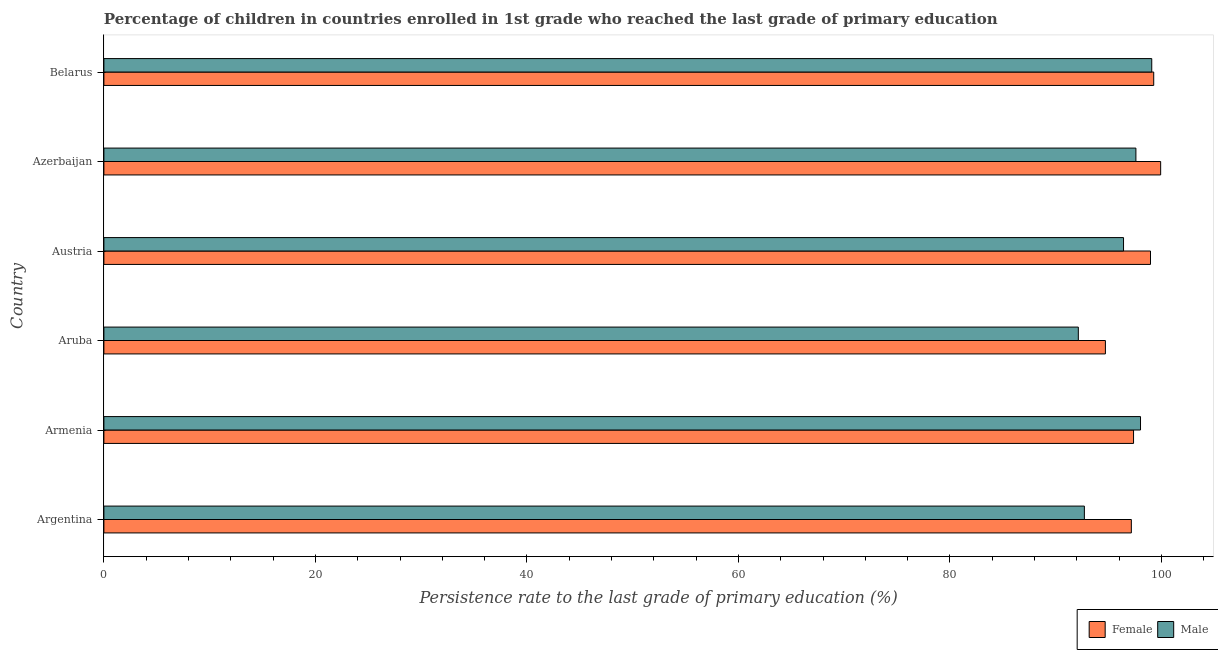How many different coloured bars are there?
Provide a short and direct response. 2. How many groups of bars are there?
Give a very brief answer. 6. Are the number of bars per tick equal to the number of legend labels?
Ensure brevity in your answer.  Yes. How many bars are there on the 4th tick from the top?
Your response must be concise. 2. What is the label of the 4th group of bars from the top?
Your answer should be compact. Aruba. What is the persistence rate of female students in Azerbaijan?
Your answer should be compact. 99.92. Across all countries, what is the maximum persistence rate of female students?
Provide a short and direct response. 99.92. Across all countries, what is the minimum persistence rate of male students?
Offer a very short reply. 92.13. In which country was the persistence rate of female students maximum?
Provide a short and direct response. Azerbaijan. In which country was the persistence rate of female students minimum?
Make the answer very short. Aruba. What is the total persistence rate of female students in the graph?
Provide a short and direct response. 587.34. What is the difference between the persistence rate of female students in Argentina and that in Aruba?
Your answer should be compact. 2.45. What is the difference between the persistence rate of female students in Argentina and the persistence rate of male students in Armenia?
Provide a succinct answer. -0.87. What is the average persistence rate of male students per country?
Your answer should be very brief. 95.99. What is the difference between the persistence rate of female students and persistence rate of male students in Aruba?
Provide a succinct answer. 2.56. In how many countries, is the persistence rate of male students greater than 44 %?
Keep it short and to the point. 6. Is the persistence rate of male students in Armenia less than that in Austria?
Your answer should be compact. No. Is the difference between the persistence rate of female students in Aruba and Belarus greater than the difference between the persistence rate of male students in Aruba and Belarus?
Keep it short and to the point. Yes. What is the difference between the highest and the second highest persistence rate of female students?
Offer a very short reply. 0.66. What is the difference between the highest and the lowest persistence rate of female students?
Make the answer very short. 5.22. In how many countries, is the persistence rate of male students greater than the average persistence rate of male students taken over all countries?
Make the answer very short. 4. Is the sum of the persistence rate of male students in Armenia and Austria greater than the maximum persistence rate of female students across all countries?
Your answer should be very brief. Yes. What does the 2nd bar from the top in Armenia represents?
Your answer should be very brief. Female. What does the 2nd bar from the bottom in Armenia represents?
Ensure brevity in your answer.  Male. How many countries are there in the graph?
Your response must be concise. 6. Are the values on the major ticks of X-axis written in scientific E-notation?
Your response must be concise. No. Where does the legend appear in the graph?
Give a very brief answer. Bottom right. How are the legend labels stacked?
Provide a succinct answer. Horizontal. What is the title of the graph?
Your response must be concise. Percentage of children in countries enrolled in 1st grade who reached the last grade of primary education. Does "Secondary Education" appear as one of the legend labels in the graph?
Ensure brevity in your answer.  No. What is the label or title of the X-axis?
Give a very brief answer. Persistence rate to the last grade of primary education (%). What is the label or title of the Y-axis?
Provide a succinct answer. Country. What is the Persistence rate to the last grade of primary education (%) of Female in Argentina?
Keep it short and to the point. 97.15. What is the Persistence rate to the last grade of primary education (%) of Male in Argentina?
Your response must be concise. 92.71. What is the Persistence rate to the last grade of primary education (%) of Female in Armenia?
Your response must be concise. 97.36. What is the Persistence rate to the last grade of primary education (%) of Male in Armenia?
Give a very brief answer. 98.01. What is the Persistence rate to the last grade of primary education (%) in Female in Aruba?
Your response must be concise. 94.7. What is the Persistence rate to the last grade of primary education (%) of Male in Aruba?
Your answer should be compact. 92.13. What is the Persistence rate to the last grade of primary education (%) in Female in Austria?
Ensure brevity in your answer.  98.96. What is the Persistence rate to the last grade of primary education (%) in Male in Austria?
Offer a very short reply. 96.41. What is the Persistence rate to the last grade of primary education (%) in Female in Azerbaijan?
Give a very brief answer. 99.92. What is the Persistence rate to the last grade of primary education (%) in Male in Azerbaijan?
Keep it short and to the point. 97.58. What is the Persistence rate to the last grade of primary education (%) of Female in Belarus?
Provide a short and direct response. 99.26. What is the Persistence rate to the last grade of primary education (%) of Male in Belarus?
Your answer should be very brief. 99.08. Across all countries, what is the maximum Persistence rate to the last grade of primary education (%) in Female?
Provide a succinct answer. 99.92. Across all countries, what is the maximum Persistence rate to the last grade of primary education (%) in Male?
Provide a succinct answer. 99.08. Across all countries, what is the minimum Persistence rate to the last grade of primary education (%) of Female?
Offer a very short reply. 94.7. Across all countries, what is the minimum Persistence rate to the last grade of primary education (%) of Male?
Your response must be concise. 92.13. What is the total Persistence rate to the last grade of primary education (%) of Female in the graph?
Your answer should be very brief. 587.34. What is the total Persistence rate to the last grade of primary education (%) in Male in the graph?
Provide a succinct answer. 575.92. What is the difference between the Persistence rate to the last grade of primary education (%) in Female in Argentina and that in Armenia?
Offer a very short reply. -0.21. What is the difference between the Persistence rate to the last grade of primary education (%) of Male in Argentina and that in Armenia?
Your answer should be very brief. -5.31. What is the difference between the Persistence rate to the last grade of primary education (%) in Female in Argentina and that in Aruba?
Give a very brief answer. 2.45. What is the difference between the Persistence rate to the last grade of primary education (%) in Male in Argentina and that in Aruba?
Make the answer very short. 0.57. What is the difference between the Persistence rate to the last grade of primary education (%) of Female in Argentina and that in Austria?
Your answer should be compact. -1.81. What is the difference between the Persistence rate to the last grade of primary education (%) of Male in Argentina and that in Austria?
Make the answer very short. -3.7. What is the difference between the Persistence rate to the last grade of primary education (%) of Female in Argentina and that in Azerbaijan?
Your answer should be compact. -2.77. What is the difference between the Persistence rate to the last grade of primary education (%) of Male in Argentina and that in Azerbaijan?
Your answer should be compact. -4.87. What is the difference between the Persistence rate to the last grade of primary education (%) of Female in Argentina and that in Belarus?
Offer a terse response. -2.11. What is the difference between the Persistence rate to the last grade of primary education (%) of Male in Argentina and that in Belarus?
Your answer should be very brief. -6.37. What is the difference between the Persistence rate to the last grade of primary education (%) of Female in Armenia and that in Aruba?
Make the answer very short. 2.66. What is the difference between the Persistence rate to the last grade of primary education (%) of Male in Armenia and that in Aruba?
Give a very brief answer. 5.88. What is the difference between the Persistence rate to the last grade of primary education (%) of Female in Armenia and that in Austria?
Your answer should be very brief. -1.6. What is the difference between the Persistence rate to the last grade of primary education (%) of Male in Armenia and that in Austria?
Make the answer very short. 1.61. What is the difference between the Persistence rate to the last grade of primary education (%) in Female in Armenia and that in Azerbaijan?
Your answer should be compact. -2.56. What is the difference between the Persistence rate to the last grade of primary education (%) in Male in Armenia and that in Azerbaijan?
Make the answer very short. 0.43. What is the difference between the Persistence rate to the last grade of primary education (%) of Female in Armenia and that in Belarus?
Make the answer very short. -1.91. What is the difference between the Persistence rate to the last grade of primary education (%) in Male in Armenia and that in Belarus?
Keep it short and to the point. -1.06. What is the difference between the Persistence rate to the last grade of primary education (%) in Female in Aruba and that in Austria?
Your answer should be compact. -4.26. What is the difference between the Persistence rate to the last grade of primary education (%) of Male in Aruba and that in Austria?
Offer a very short reply. -4.28. What is the difference between the Persistence rate to the last grade of primary education (%) of Female in Aruba and that in Azerbaijan?
Ensure brevity in your answer.  -5.22. What is the difference between the Persistence rate to the last grade of primary education (%) in Male in Aruba and that in Azerbaijan?
Offer a terse response. -5.45. What is the difference between the Persistence rate to the last grade of primary education (%) in Female in Aruba and that in Belarus?
Your answer should be very brief. -4.57. What is the difference between the Persistence rate to the last grade of primary education (%) of Male in Aruba and that in Belarus?
Offer a very short reply. -6.94. What is the difference between the Persistence rate to the last grade of primary education (%) of Female in Austria and that in Azerbaijan?
Keep it short and to the point. -0.96. What is the difference between the Persistence rate to the last grade of primary education (%) of Male in Austria and that in Azerbaijan?
Your answer should be compact. -1.17. What is the difference between the Persistence rate to the last grade of primary education (%) in Female in Austria and that in Belarus?
Your response must be concise. -0.3. What is the difference between the Persistence rate to the last grade of primary education (%) in Male in Austria and that in Belarus?
Your response must be concise. -2.67. What is the difference between the Persistence rate to the last grade of primary education (%) of Female in Azerbaijan and that in Belarus?
Ensure brevity in your answer.  0.66. What is the difference between the Persistence rate to the last grade of primary education (%) in Male in Azerbaijan and that in Belarus?
Provide a short and direct response. -1.5. What is the difference between the Persistence rate to the last grade of primary education (%) of Female in Argentina and the Persistence rate to the last grade of primary education (%) of Male in Armenia?
Ensure brevity in your answer.  -0.87. What is the difference between the Persistence rate to the last grade of primary education (%) in Female in Argentina and the Persistence rate to the last grade of primary education (%) in Male in Aruba?
Make the answer very short. 5.01. What is the difference between the Persistence rate to the last grade of primary education (%) of Female in Argentina and the Persistence rate to the last grade of primary education (%) of Male in Austria?
Ensure brevity in your answer.  0.74. What is the difference between the Persistence rate to the last grade of primary education (%) in Female in Argentina and the Persistence rate to the last grade of primary education (%) in Male in Azerbaijan?
Give a very brief answer. -0.43. What is the difference between the Persistence rate to the last grade of primary education (%) of Female in Argentina and the Persistence rate to the last grade of primary education (%) of Male in Belarus?
Your answer should be compact. -1.93. What is the difference between the Persistence rate to the last grade of primary education (%) of Female in Armenia and the Persistence rate to the last grade of primary education (%) of Male in Aruba?
Your answer should be very brief. 5.22. What is the difference between the Persistence rate to the last grade of primary education (%) of Female in Armenia and the Persistence rate to the last grade of primary education (%) of Male in Austria?
Provide a succinct answer. 0.95. What is the difference between the Persistence rate to the last grade of primary education (%) of Female in Armenia and the Persistence rate to the last grade of primary education (%) of Male in Azerbaijan?
Ensure brevity in your answer.  -0.22. What is the difference between the Persistence rate to the last grade of primary education (%) in Female in Armenia and the Persistence rate to the last grade of primary education (%) in Male in Belarus?
Give a very brief answer. -1.72. What is the difference between the Persistence rate to the last grade of primary education (%) in Female in Aruba and the Persistence rate to the last grade of primary education (%) in Male in Austria?
Keep it short and to the point. -1.71. What is the difference between the Persistence rate to the last grade of primary education (%) in Female in Aruba and the Persistence rate to the last grade of primary education (%) in Male in Azerbaijan?
Your answer should be compact. -2.88. What is the difference between the Persistence rate to the last grade of primary education (%) in Female in Aruba and the Persistence rate to the last grade of primary education (%) in Male in Belarus?
Your answer should be compact. -4.38. What is the difference between the Persistence rate to the last grade of primary education (%) of Female in Austria and the Persistence rate to the last grade of primary education (%) of Male in Azerbaijan?
Offer a very short reply. 1.38. What is the difference between the Persistence rate to the last grade of primary education (%) of Female in Austria and the Persistence rate to the last grade of primary education (%) of Male in Belarus?
Provide a succinct answer. -0.12. What is the difference between the Persistence rate to the last grade of primary education (%) in Female in Azerbaijan and the Persistence rate to the last grade of primary education (%) in Male in Belarus?
Your response must be concise. 0.84. What is the average Persistence rate to the last grade of primary education (%) in Female per country?
Provide a succinct answer. 97.89. What is the average Persistence rate to the last grade of primary education (%) of Male per country?
Your answer should be very brief. 95.99. What is the difference between the Persistence rate to the last grade of primary education (%) in Female and Persistence rate to the last grade of primary education (%) in Male in Argentina?
Give a very brief answer. 4.44. What is the difference between the Persistence rate to the last grade of primary education (%) in Female and Persistence rate to the last grade of primary education (%) in Male in Armenia?
Provide a succinct answer. -0.66. What is the difference between the Persistence rate to the last grade of primary education (%) in Female and Persistence rate to the last grade of primary education (%) in Male in Aruba?
Your answer should be very brief. 2.56. What is the difference between the Persistence rate to the last grade of primary education (%) of Female and Persistence rate to the last grade of primary education (%) of Male in Austria?
Your response must be concise. 2.55. What is the difference between the Persistence rate to the last grade of primary education (%) of Female and Persistence rate to the last grade of primary education (%) of Male in Azerbaijan?
Make the answer very short. 2.34. What is the difference between the Persistence rate to the last grade of primary education (%) in Female and Persistence rate to the last grade of primary education (%) in Male in Belarus?
Offer a very short reply. 0.18. What is the ratio of the Persistence rate to the last grade of primary education (%) of Male in Argentina to that in Armenia?
Your answer should be compact. 0.95. What is the ratio of the Persistence rate to the last grade of primary education (%) in Female in Argentina to that in Aruba?
Your response must be concise. 1.03. What is the ratio of the Persistence rate to the last grade of primary education (%) in Male in Argentina to that in Aruba?
Offer a very short reply. 1.01. What is the ratio of the Persistence rate to the last grade of primary education (%) in Female in Argentina to that in Austria?
Give a very brief answer. 0.98. What is the ratio of the Persistence rate to the last grade of primary education (%) in Male in Argentina to that in Austria?
Provide a succinct answer. 0.96. What is the ratio of the Persistence rate to the last grade of primary education (%) in Female in Argentina to that in Azerbaijan?
Keep it short and to the point. 0.97. What is the ratio of the Persistence rate to the last grade of primary education (%) in Male in Argentina to that in Azerbaijan?
Ensure brevity in your answer.  0.95. What is the ratio of the Persistence rate to the last grade of primary education (%) in Female in Argentina to that in Belarus?
Your response must be concise. 0.98. What is the ratio of the Persistence rate to the last grade of primary education (%) of Male in Argentina to that in Belarus?
Ensure brevity in your answer.  0.94. What is the ratio of the Persistence rate to the last grade of primary education (%) in Female in Armenia to that in Aruba?
Ensure brevity in your answer.  1.03. What is the ratio of the Persistence rate to the last grade of primary education (%) of Male in Armenia to that in Aruba?
Offer a terse response. 1.06. What is the ratio of the Persistence rate to the last grade of primary education (%) in Female in Armenia to that in Austria?
Provide a short and direct response. 0.98. What is the ratio of the Persistence rate to the last grade of primary education (%) of Male in Armenia to that in Austria?
Ensure brevity in your answer.  1.02. What is the ratio of the Persistence rate to the last grade of primary education (%) in Female in Armenia to that in Azerbaijan?
Give a very brief answer. 0.97. What is the ratio of the Persistence rate to the last grade of primary education (%) in Male in Armenia to that in Azerbaijan?
Provide a succinct answer. 1. What is the ratio of the Persistence rate to the last grade of primary education (%) of Female in Armenia to that in Belarus?
Offer a very short reply. 0.98. What is the ratio of the Persistence rate to the last grade of primary education (%) of Male in Armenia to that in Belarus?
Make the answer very short. 0.99. What is the ratio of the Persistence rate to the last grade of primary education (%) in Female in Aruba to that in Austria?
Give a very brief answer. 0.96. What is the ratio of the Persistence rate to the last grade of primary education (%) of Male in Aruba to that in Austria?
Ensure brevity in your answer.  0.96. What is the ratio of the Persistence rate to the last grade of primary education (%) in Female in Aruba to that in Azerbaijan?
Provide a succinct answer. 0.95. What is the ratio of the Persistence rate to the last grade of primary education (%) in Male in Aruba to that in Azerbaijan?
Make the answer very short. 0.94. What is the ratio of the Persistence rate to the last grade of primary education (%) of Female in Aruba to that in Belarus?
Ensure brevity in your answer.  0.95. What is the ratio of the Persistence rate to the last grade of primary education (%) in Male in Aruba to that in Belarus?
Your response must be concise. 0.93. What is the ratio of the Persistence rate to the last grade of primary education (%) of Female in Austria to that in Azerbaijan?
Your answer should be very brief. 0.99. What is the ratio of the Persistence rate to the last grade of primary education (%) of Male in Austria to that in Azerbaijan?
Your answer should be compact. 0.99. What is the ratio of the Persistence rate to the last grade of primary education (%) of Male in Austria to that in Belarus?
Give a very brief answer. 0.97. What is the ratio of the Persistence rate to the last grade of primary education (%) in Female in Azerbaijan to that in Belarus?
Offer a very short reply. 1.01. What is the ratio of the Persistence rate to the last grade of primary education (%) in Male in Azerbaijan to that in Belarus?
Provide a short and direct response. 0.98. What is the difference between the highest and the second highest Persistence rate to the last grade of primary education (%) in Female?
Ensure brevity in your answer.  0.66. What is the difference between the highest and the second highest Persistence rate to the last grade of primary education (%) of Male?
Offer a very short reply. 1.06. What is the difference between the highest and the lowest Persistence rate to the last grade of primary education (%) of Female?
Provide a short and direct response. 5.22. What is the difference between the highest and the lowest Persistence rate to the last grade of primary education (%) in Male?
Keep it short and to the point. 6.94. 